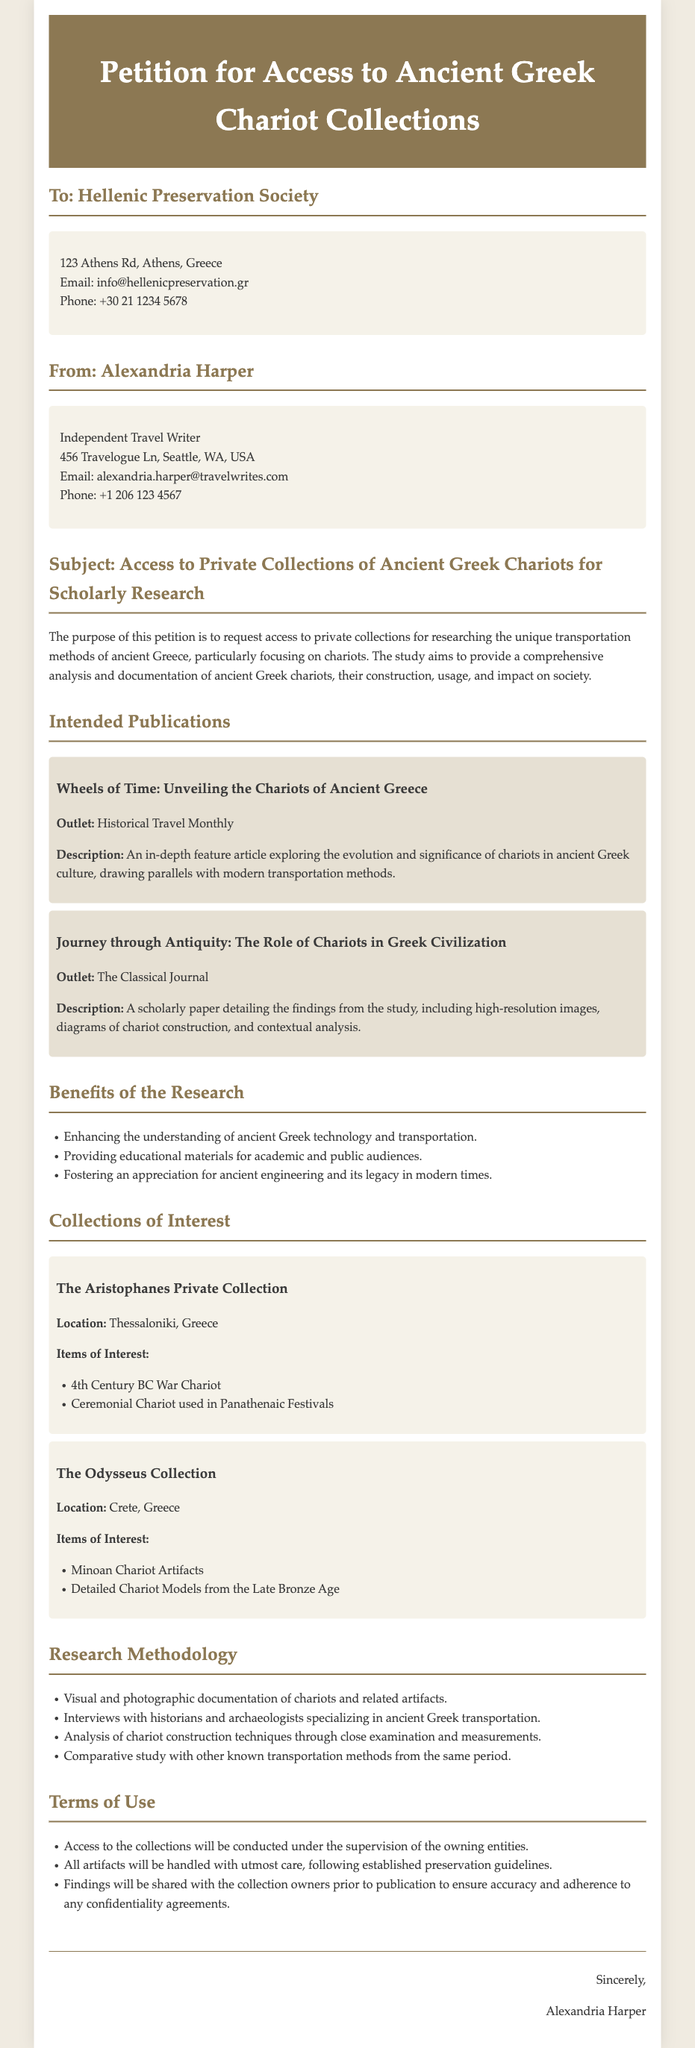what is the name of the petition's author? The petition is authored by an independent travel writer named Alexandria Harper.
Answer: Alexandria Harper which organization is the petition addressed to? The petition is directed towards the Hellenic Preservation Society, which is indicated in the opening section of the document.
Answer: Hellenic Preservation Society how many intended publications are listed in the document? There are two intended publications mentioned in the document under the section "Intended Publications."
Answer: 2 what is one item of interest in The Aristophanes Private Collection? The document lists specific items of interest in The Aristophanes Private Collection, one of which is a 4th Century BC War Chariot.
Answer: 4th Century BC War Chariot which location houses The Odysseus Collection? The location of The Odysseus Collection is stated as Crete, Greece.
Answer: Crete, Greece what method involves examining and measuring chariot construction techniques? The research methodology includes analysis of chariot construction techniques through close examination and measurements.
Answer: close examination and measurements what is the focus of the research described in the petition? The purpose of the research is to study the unique transportation methods of ancient Greece, specifically centered on chariots.
Answer: unique transportation methods of ancient Greece how will the collection owners be involved in the research findings? Findings will be shared with the collection owners prior to publication to ensure accuracy.
Answer: shared with the collection owners how will access to the collections be monitored? Access will be conducted under the supervision of the owning entities as stated in the terms.
Answer: supervision of the owning entities 